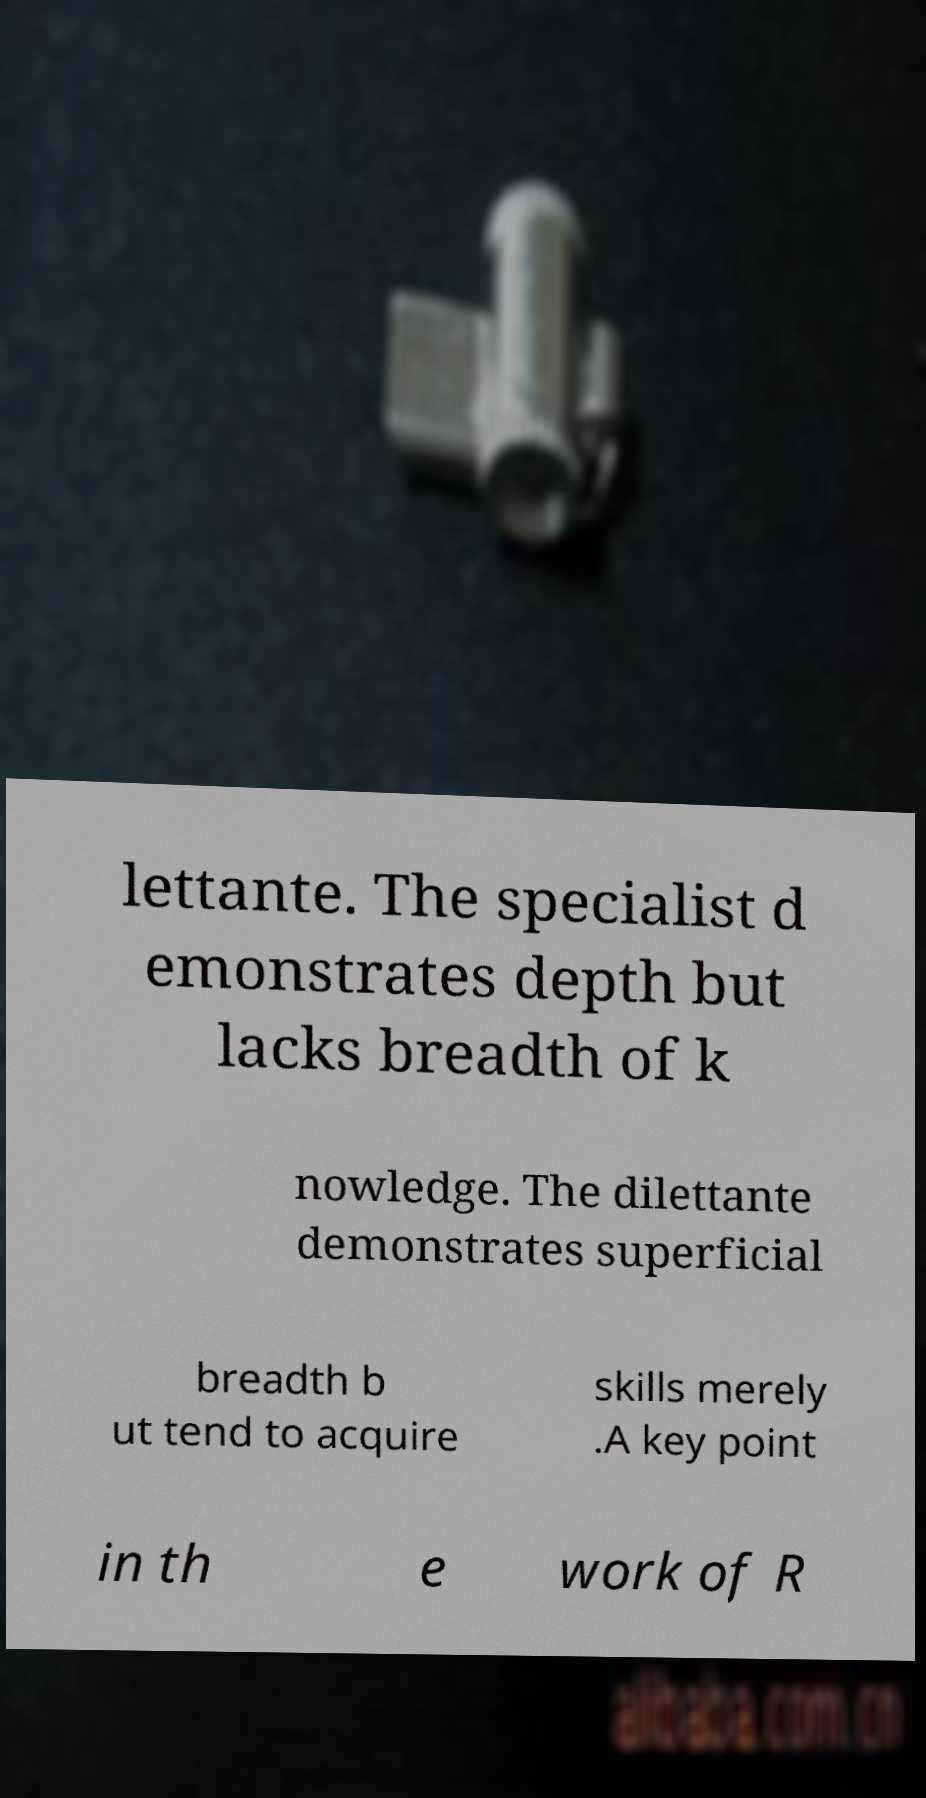Could you extract and type out the text from this image? lettante. The specialist d emonstrates depth but lacks breadth of k nowledge. The dilettante demonstrates superficial breadth b ut tend to acquire skills merely .A key point in th e work of R 